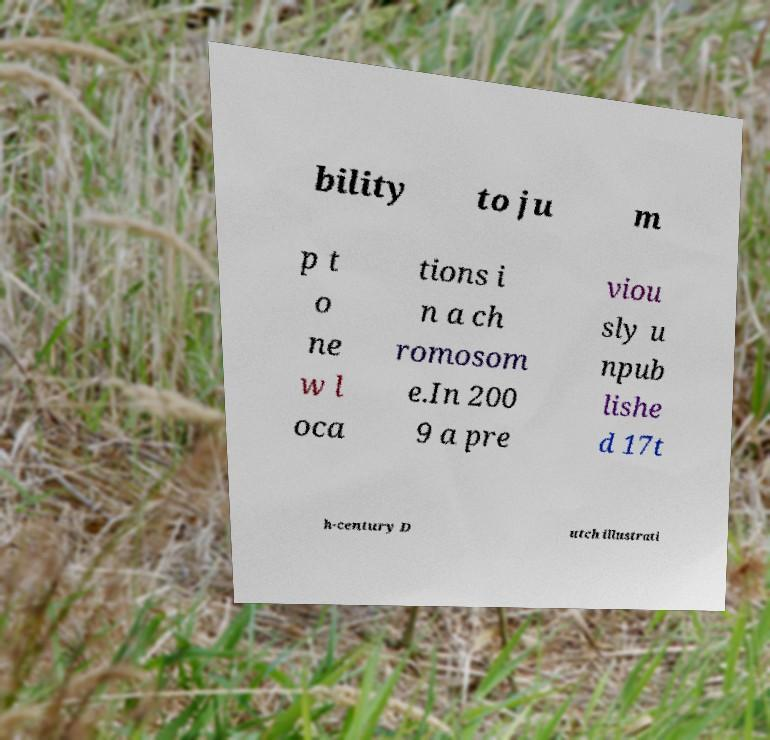I need the written content from this picture converted into text. Can you do that? bility to ju m p t o ne w l oca tions i n a ch romosom e.In 200 9 a pre viou sly u npub lishe d 17t h-century D utch illustrati 